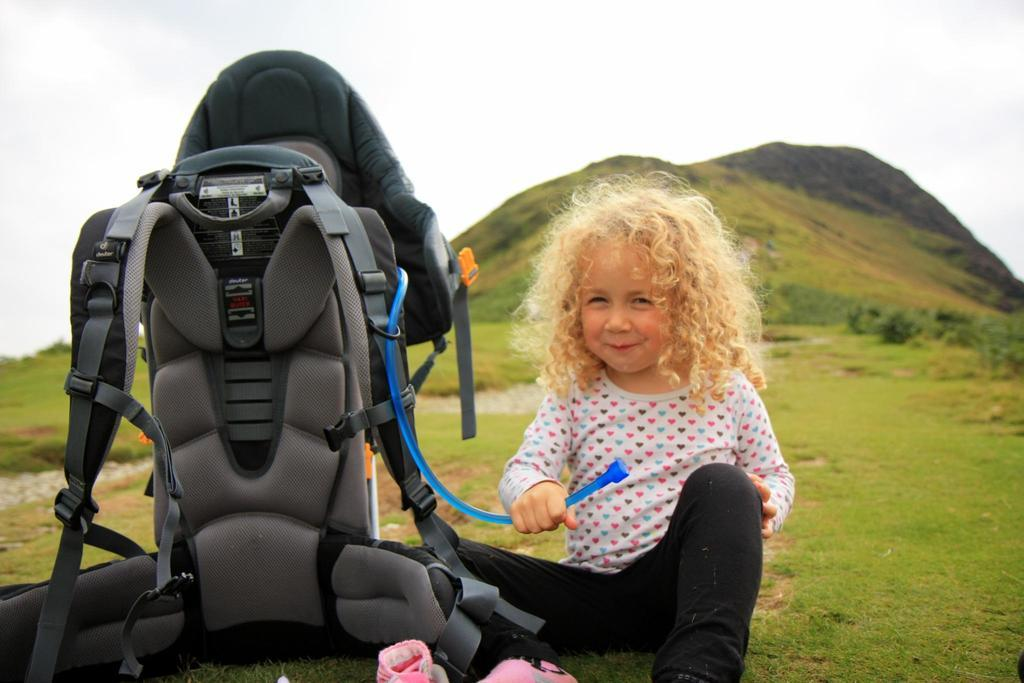Who is the main subject in the image? There is a girl in the image. What is the girl doing in the image? The girl is sitting on the ground. What object is beside the girl? There is a safety bag beside the girl. What type of surface is the girl sitting on? The ground is covered with grass. What type of curve can be seen in the girl's hair in the image? There is no curve visible in the girl's hair in the image. 